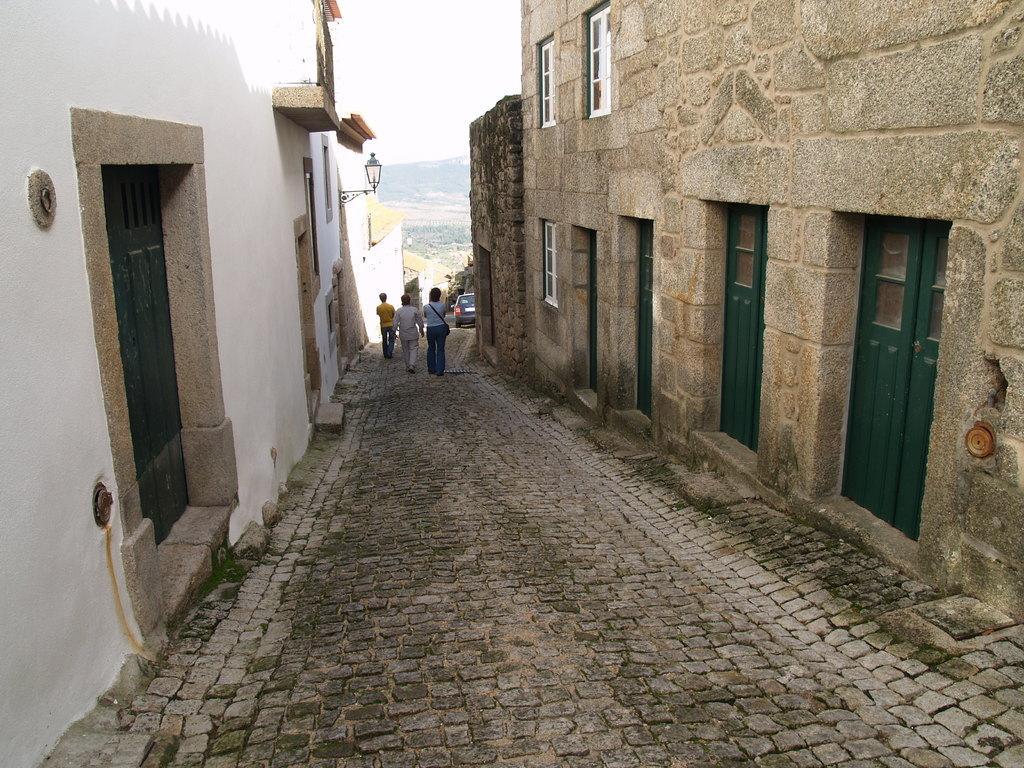In one or two sentences, can you explain what this image depicts? This picture is clicked outside. On both the sides we can see the houses and we can see the doors and windows of the houses. In the center there is a vehicle and we can see the group of persons walking on the pavement and there is a lamp attached to the wall of a house. In the background there is a sky and some other items. 